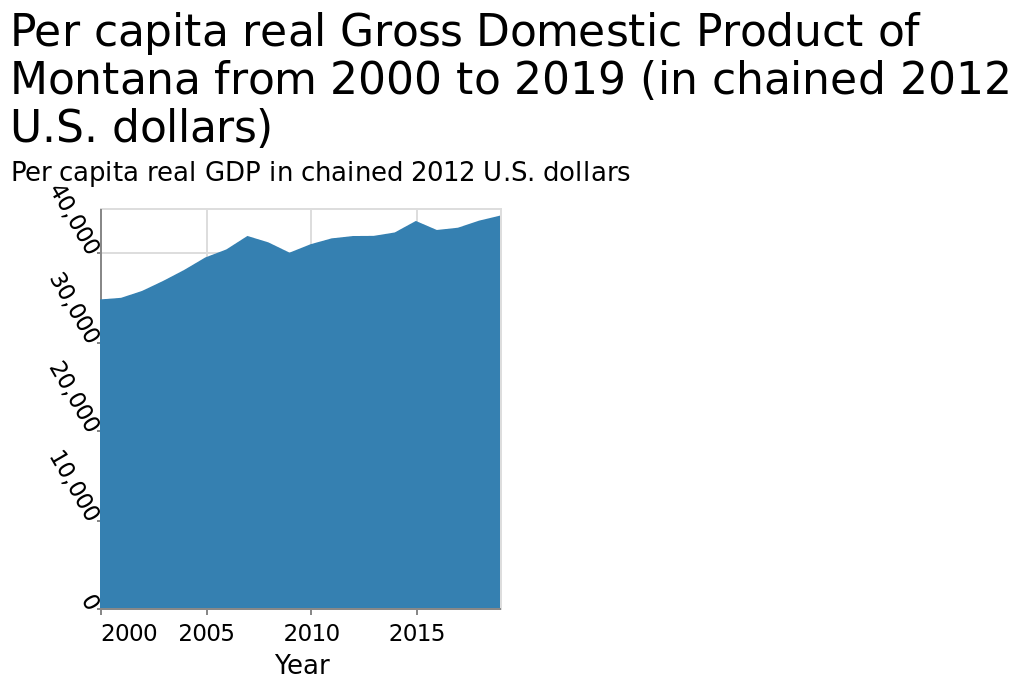<image>
please summary the statistics and relations of the chart The gdp per capita was higher at the end than at the beginning. There were two peaks along the way but it dropped back afterwards. Was the GDP per capita higher at the end compared to the beginning?  Yes, the GDP per capita was higher at the end than at the beginning. What is the range of years covered in the area chart? The area chart covers the years from 2000 to 2019. 